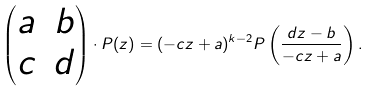<formula> <loc_0><loc_0><loc_500><loc_500>\begin{pmatrix} a & b \\ c & d \end{pmatrix} \cdot P ( z ) = ( - c z + a ) ^ { k - 2 } P \left ( \frac { d z - b } { - c z + a } \right ) .</formula> 